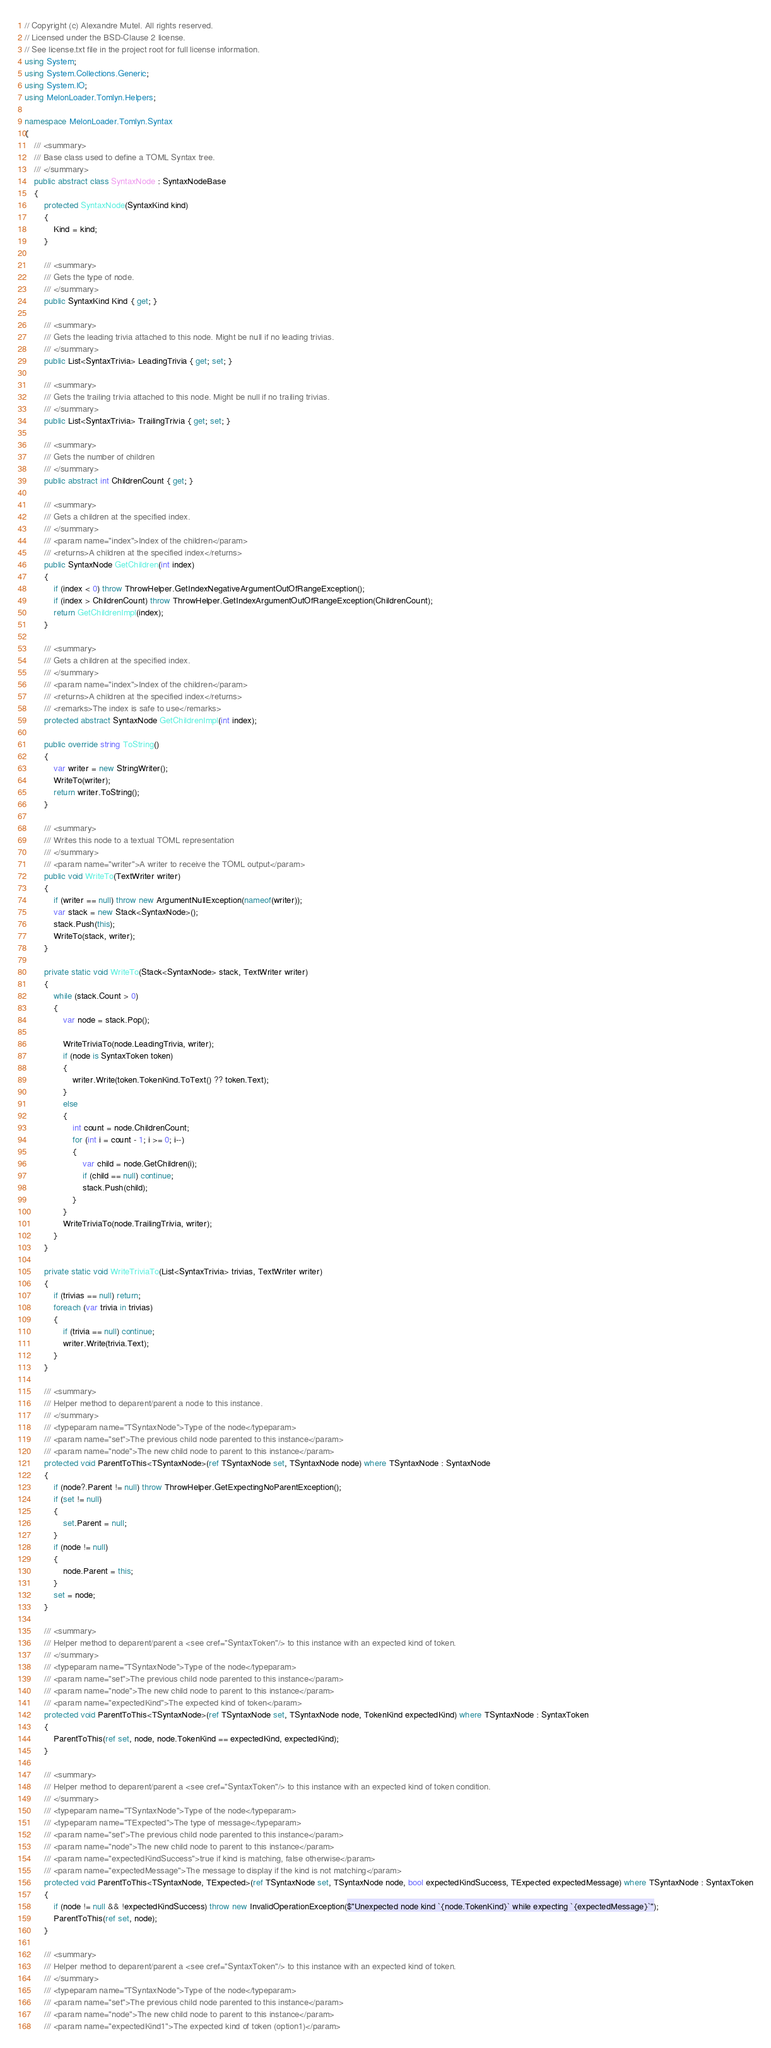Convert code to text. <code><loc_0><loc_0><loc_500><loc_500><_C#_>// Copyright (c) Alexandre Mutel. All rights reserved.
// Licensed under the BSD-Clause 2 license. 
// See license.txt file in the project root for full license information.
using System;
using System.Collections.Generic;
using System.IO;
using MelonLoader.Tomlyn.Helpers;

namespace MelonLoader.Tomlyn.Syntax
{
    /// <summary>
    /// Base class used to define a TOML Syntax tree.
    /// </summary>
    public abstract class SyntaxNode : SyntaxNodeBase
    {
        protected SyntaxNode(SyntaxKind kind)
        {
            Kind = kind;
        }

        /// <summary>
        /// Gets the type of node.
        /// </summary>
        public SyntaxKind Kind { get; }

        /// <summary>
        /// Gets the leading trivia attached to this node. Might be null if no leading trivias.
        /// </summary>
        public List<SyntaxTrivia> LeadingTrivia { get; set; }

        /// <summary>
        /// Gets the trailing trivia attached to this node. Might be null if no trailing trivias.
        /// </summary>
        public List<SyntaxTrivia> TrailingTrivia { get; set; }

        /// <summary>
        /// Gets the number of children
        /// </summary>
        public abstract int ChildrenCount { get; }

        /// <summary>
        /// Gets a children at the specified index.
        /// </summary>
        /// <param name="index">Index of the children</param>
        /// <returns>A children at the specified index</returns>
        public SyntaxNode GetChildren(int index)
        {
            if (index < 0) throw ThrowHelper.GetIndexNegativeArgumentOutOfRangeException();
            if (index > ChildrenCount) throw ThrowHelper.GetIndexArgumentOutOfRangeException(ChildrenCount);
            return GetChildrenImpl(index);
        }

        /// <summary>
        /// Gets a children at the specified index.
        /// </summary>
        /// <param name="index">Index of the children</param>
        /// <returns>A children at the specified index</returns>
        /// <remarks>The index is safe to use</remarks>
        protected abstract SyntaxNode GetChildrenImpl(int index);

        public override string ToString()
        {
            var writer = new StringWriter();
            WriteTo(writer);
            return writer.ToString();
        }

        /// <summary>
        /// Writes this node to a textual TOML representation
        /// </summary>
        /// <param name="writer">A writer to receive the TOML output</param>
        public void WriteTo(TextWriter writer)
        {
            if (writer == null) throw new ArgumentNullException(nameof(writer));
            var stack = new Stack<SyntaxNode>();
            stack.Push(this);
            WriteTo(stack, writer);
        }

        private static void WriteTo(Stack<SyntaxNode> stack, TextWriter writer)
        {
            while (stack.Count > 0)
            {
                var node = stack.Pop();

                WriteTriviaTo(node.LeadingTrivia, writer);
                if (node is SyntaxToken token)
                {
                    writer.Write(token.TokenKind.ToText() ?? token.Text);
                }
                else
                {
                    int count = node.ChildrenCount;
                    for (int i = count - 1; i >= 0; i--)
                    {
                        var child = node.GetChildren(i);
                        if (child == null) continue;
                        stack.Push(child);
                    }
                }
                WriteTriviaTo(node.TrailingTrivia, writer);
            }
        }

        private static void WriteTriviaTo(List<SyntaxTrivia> trivias, TextWriter writer)
        {
            if (trivias == null) return;
            foreach (var trivia in trivias)
            {
                if (trivia == null) continue;
                writer.Write(trivia.Text);
            }
        }

        /// <summary>
        /// Helper method to deparent/parent a node to this instance.
        /// </summary>
        /// <typeparam name="TSyntaxNode">Type of the node</typeparam>
        /// <param name="set">The previous child node parented to this instance</param>
        /// <param name="node">The new child node to parent to this instance</param>
        protected void ParentToThis<TSyntaxNode>(ref TSyntaxNode set, TSyntaxNode node) where TSyntaxNode : SyntaxNode
        {
            if (node?.Parent != null) throw ThrowHelper.GetExpectingNoParentException();
            if (set != null)
            {
                set.Parent = null;
            }
            if (node != null)
            {
                node.Parent = this;
            }
            set = node;
        }

        /// <summary>
        /// Helper method to deparent/parent a <see cref="SyntaxToken"/> to this instance with an expected kind of token.
        /// </summary>
        /// <typeparam name="TSyntaxNode">Type of the node</typeparam>
        /// <param name="set">The previous child node parented to this instance</param>
        /// <param name="node">The new child node to parent to this instance</param>
        /// <param name="expectedKind">The expected kind of token</param>
        protected void ParentToThis<TSyntaxNode>(ref TSyntaxNode set, TSyntaxNode node, TokenKind expectedKind) where TSyntaxNode : SyntaxToken
        {
            ParentToThis(ref set, node, node.TokenKind == expectedKind, expectedKind);
        }

        /// <summary>
        /// Helper method to deparent/parent a <see cref="SyntaxToken"/> to this instance with an expected kind of token condition.
        /// </summary>
        /// <typeparam name="TSyntaxNode">Type of the node</typeparam>
        /// <typeparam name="TExpected">The type of message</typeparam>
        /// <param name="set">The previous child node parented to this instance</param>
        /// <param name="node">The new child node to parent to this instance</param>
        /// <param name="expectedKindSuccess">true if kind is matching, false otherwise</param>
        /// <param name="expectedMessage">The message to display if the kind is not matching</param>
        protected void ParentToThis<TSyntaxNode, TExpected>(ref TSyntaxNode set, TSyntaxNode node, bool expectedKindSuccess, TExpected expectedMessage) where TSyntaxNode : SyntaxToken
        {
            if (node != null && !expectedKindSuccess) throw new InvalidOperationException($"Unexpected node kind `{node.TokenKind}` while expecting `{expectedMessage}`");
            ParentToThis(ref set, node);
        }

        /// <summary>
        /// Helper method to deparent/parent a <see cref="SyntaxToken"/> to this instance with an expected kind of token.
        /// </summary>
        /// <typeparam name="TSyntaxNode">Type of the node</typeparam>
        /// <param name="set">The previous child node parented to this instance</param>
        /// <param name="node">The new child node to parent to this instance</param>
        /// <param name="expectedKind1">The expected kind of token (option1)</param></code> 